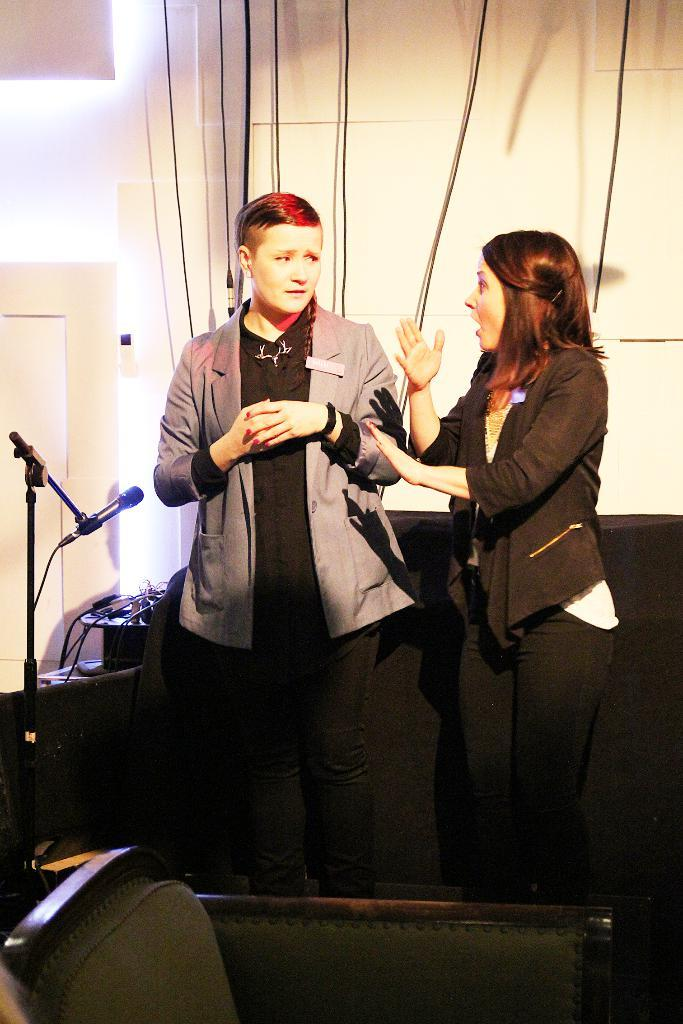How many people are in the image? There are two persons standing in the image. What object is present that is typically used for amplifying sound? There is a microphone (mike) in the image. What piece of furniture can be seen in the image? There is a chair in the image. What type of electrical components are visible in the image? There are cables and wires in the image. What type of structure is visible in the background of the image? There is a wall in the background of the image. What architectural feature can be seen in the background of the image? There is a door in the background of the image. What is the level of pollution in the image? There is no indication of pollution in the image; it does not contain any information about air quality or environmental conditions. 